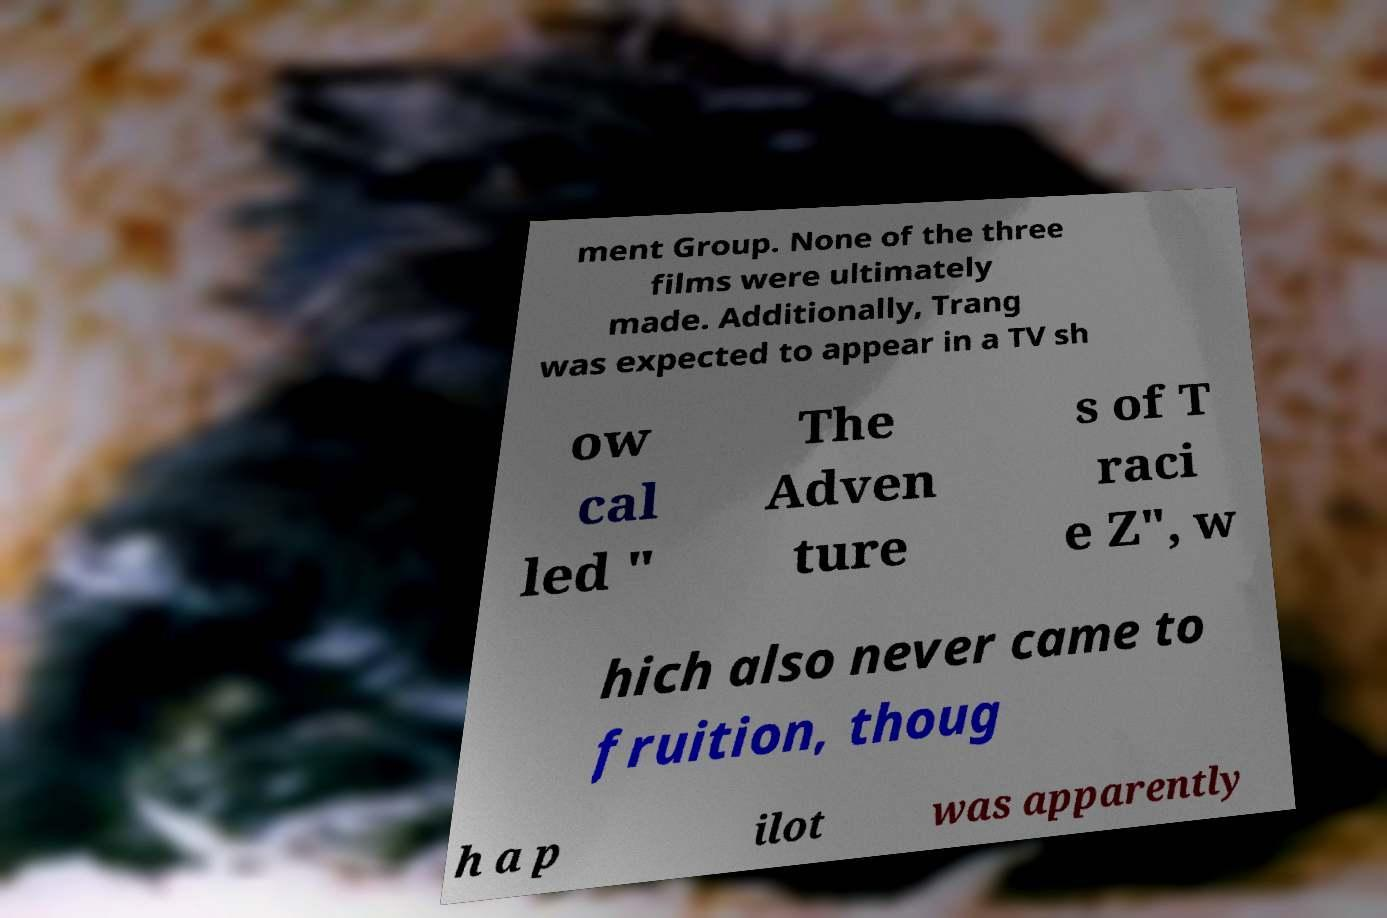I need the written content from this picture converted into text. Can you do that? ment Group. None of the three films were ultimately made. Additionally, Trang was expected to appear in a TV sh ow cal led " The Adven ture s of T raci e Z", w hich also never came to fruition, thoug h a p ilot was apparently 